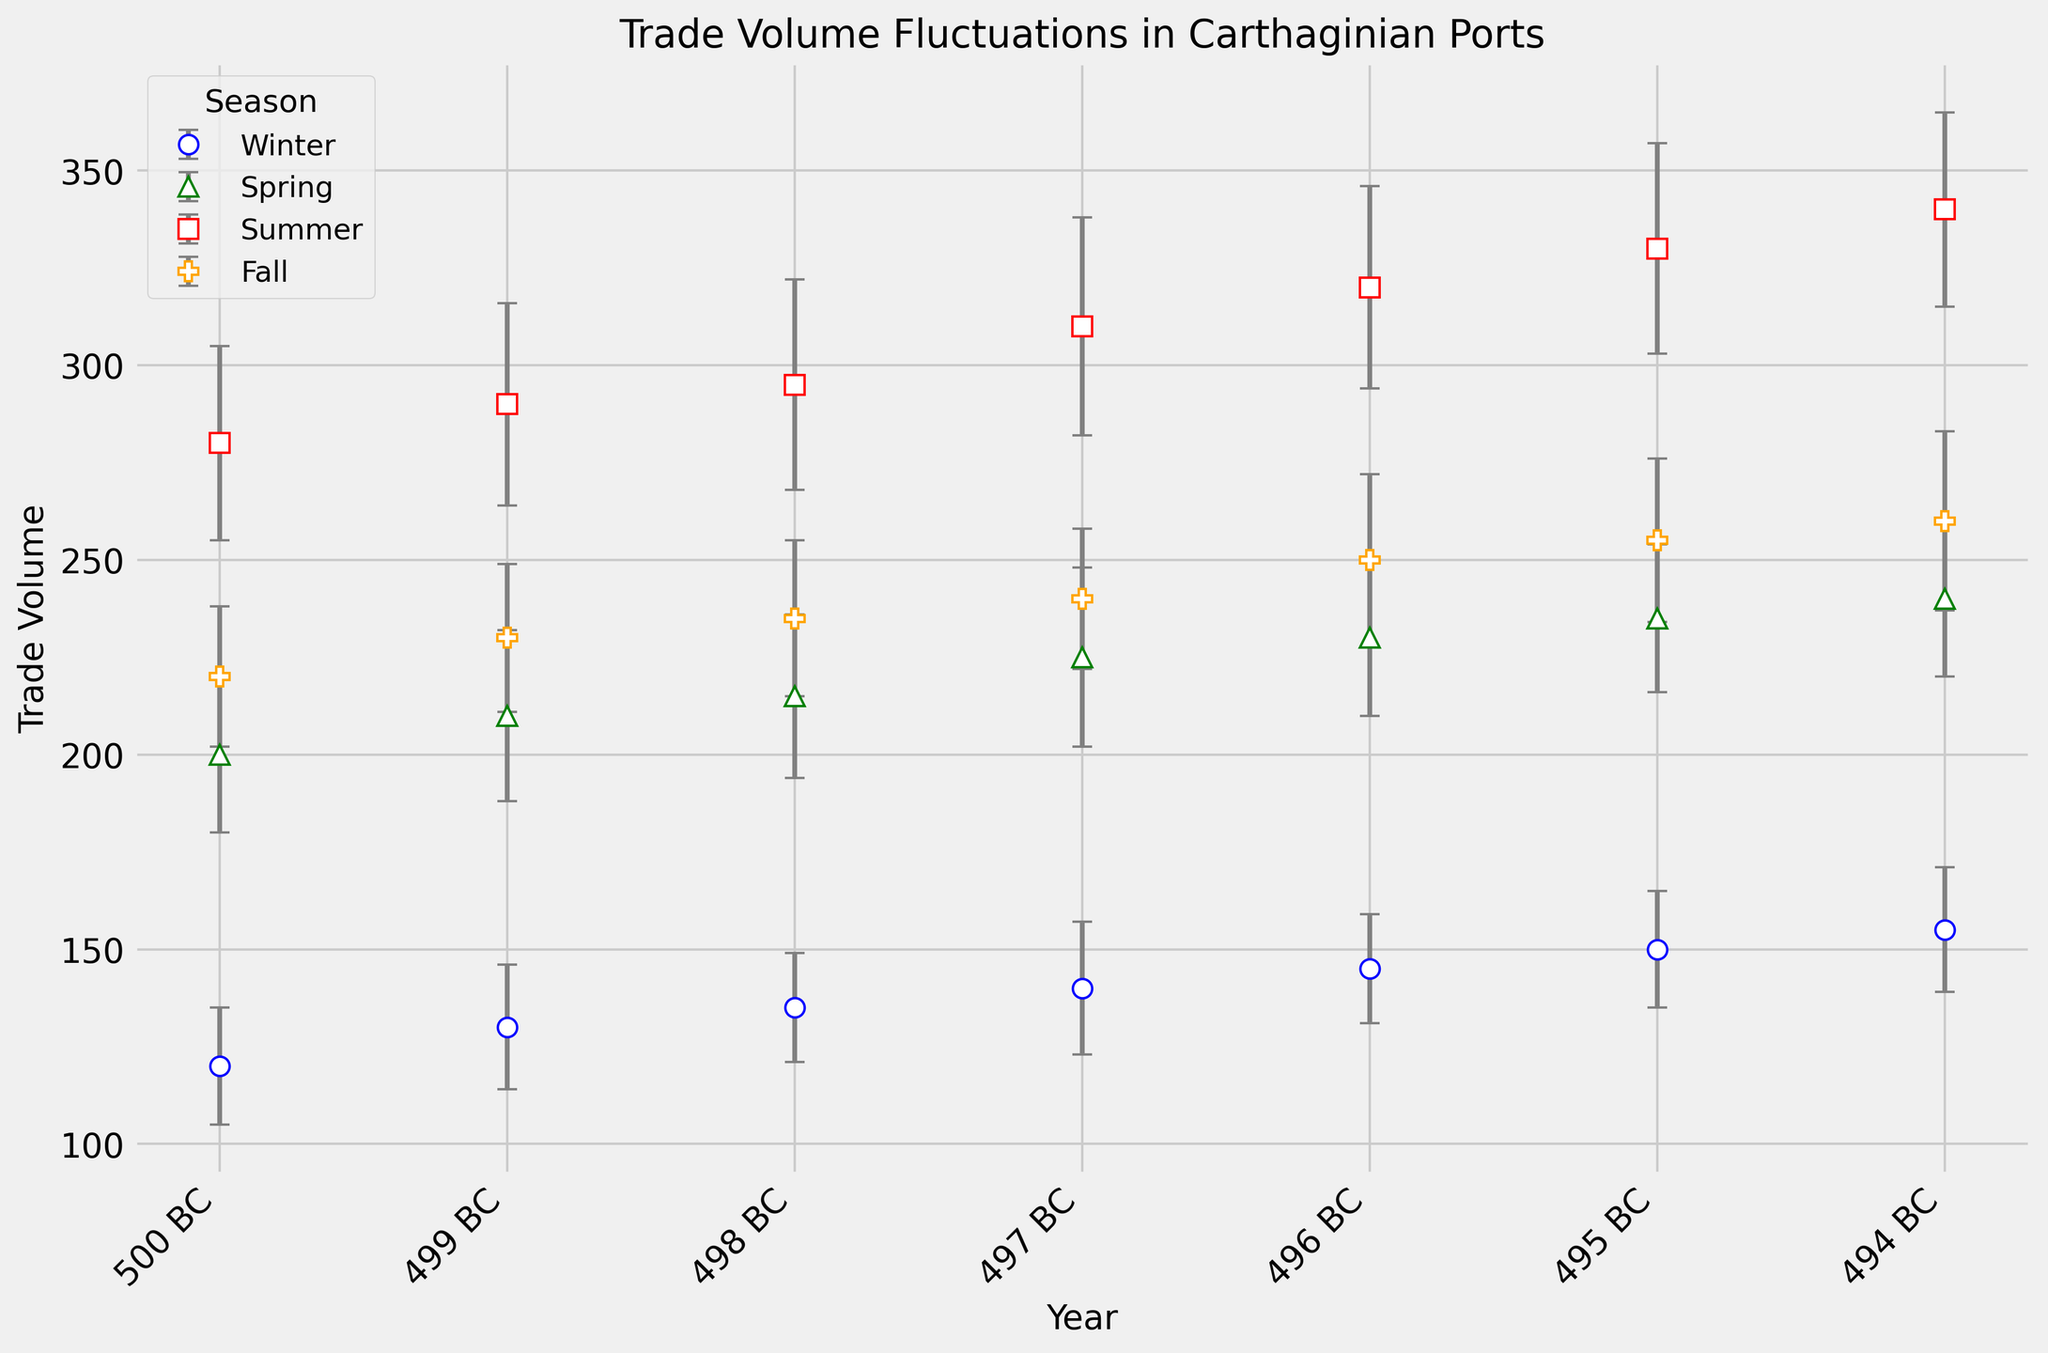What's the overall trend in trade volume from 500 BC to 494 BC for all seasons? By observing the plot, the trade volume for every season generally increases over the years from 500 BC to 494 BC. This trend can be seen in every seasonal marker's ascending pattern.
Answer: Increasing Which season shows the most significant increase in trade volume from 500 BC to 494 BC? Look at the seasonal lines from the start to the end year. Summer has the most significant increase, starting at 280 and ending at 340, a change of 60 units.
Answer: Summer What is the average trade volume for Spring over the given years? To calculate the average, sum the trade volumes for Spring and divide by the number of years. (200 + 210 + 215 + 225 + 230 + 235 + 240) / 7 = 210.71
Answer: 210.71 Which season has the smallest trade volume increase over the years and what is the amount? Comparing the increase from 500 BC to 494 BC for all seasons, Winter starts at 120 and ends at 155, an increase of 35 units. This is the smallest compared to other seasons.
Answer: Winter, 35 units What is the visual color used for representing Fall, and why is this significant for interpretation? Notice the color coding of the plot markers and lines. Fall is represented with orange color. Recognizing the color helps distinguish and interpret seasonal trends easily.
Answer: Orange How does the trade volume in Winter of 494 BC compare to the trade volume in Winter of 500 BC? Compare the values for Winter in both years. Winter in 494 BC has a trade volume of 155, while in Winter of 500 BC, it is 120. So, 155 is greater than 120 by 35 units.
Answer: 155 is 35 units higher In which year and season combination is the trade volume 290? Locate the point with the trade volume of 290 on the plot. It is for Summer in 499 BC.
Answer: Summer, 499 BC What is the error margin for trade volume in Summer of 496 BC? Refer to the error bars for Summer of 496 BC. The Standard Error given is 26 units.
Answer: 26 units 